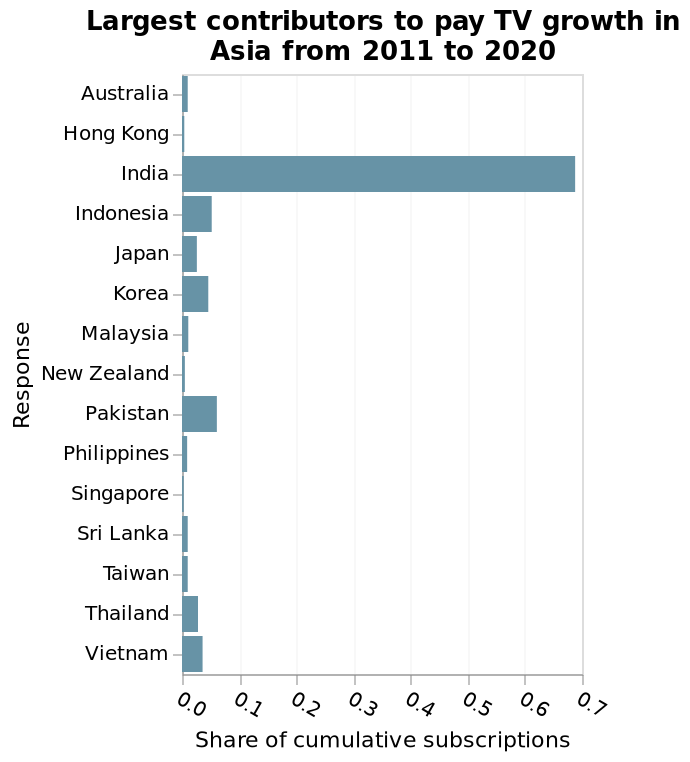<image>
please summary the statistics and relations of the chart The chart shows that india has the greatest share of cumulative subscriptions, by a huge amount. India's share is shown as almost 0.7, whereas all other countries are shown at a figure of less than 0.1. Singapore, New Zealand and Hong Kong all appear to have virtually zero share. Was India the largest contributor to pay TV among all countries? No, the description only states that India was the largest contributor among Asian countries. Which country was the largest contributor to pay TV among Asian countries?  India was the largest contributor to pay TV among Asian countries. Describe the following image in detail Here a bar diagram is labeled Largest contributors to pay TV growth in Asia from 2011 to 2020. On the x-axis, Share of cumulative subscriptions is shown using a scale with a minimum of 0.0 and a maximum of 0.7. There is a categorical scale starting with Australia and ending with Vietnam on the y-axis, labeled Response. 